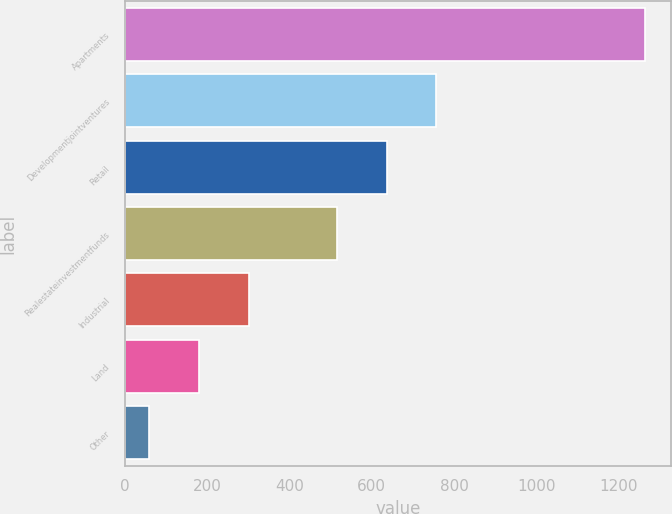Convert chart. <chart><loc_0><loc_0><loc_500><loc_500><bar_chart><fcel>Apartments<fcel>Developmentjointventures<fcel>Retail<fcel>Realestateinvestmentfunds<fcel>Industrial<fcel>Land<fcel>Other<nl><fcel>1264<fcel>756.8<fcel>636.4<fcel>516<fcel>300.8<fcel>180.4<fcel>60<nl></chart> 